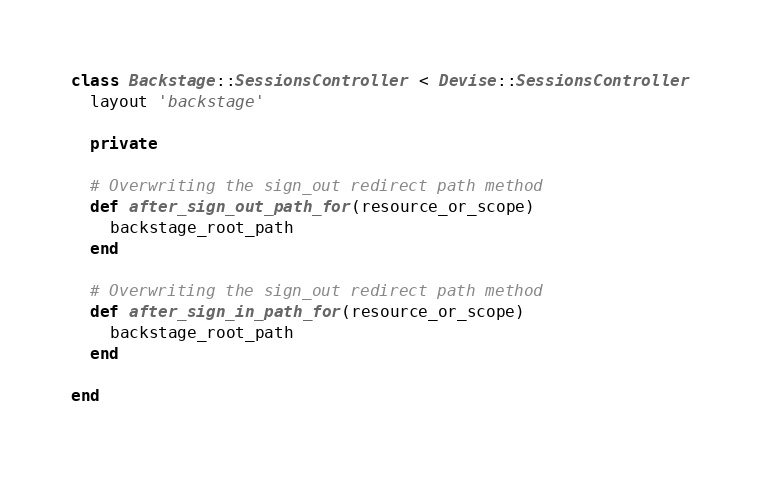<code> <loc_0><loc_0><loc_500><loc_500><_Ruby_>class Backstage::SessionsController < Devise::SessionsController
  layout 'backstage'

  private

  # Overwriting the sign_out redirect path method
  def after_sign_out_path_for(resource_or_scope)
    backstage_root_path
  end

  # Overwriting the sign_out redirect path method
  def after_sign_in_path_for(resource_or_scope)
    backstage_root_path
  end

end
</code> 